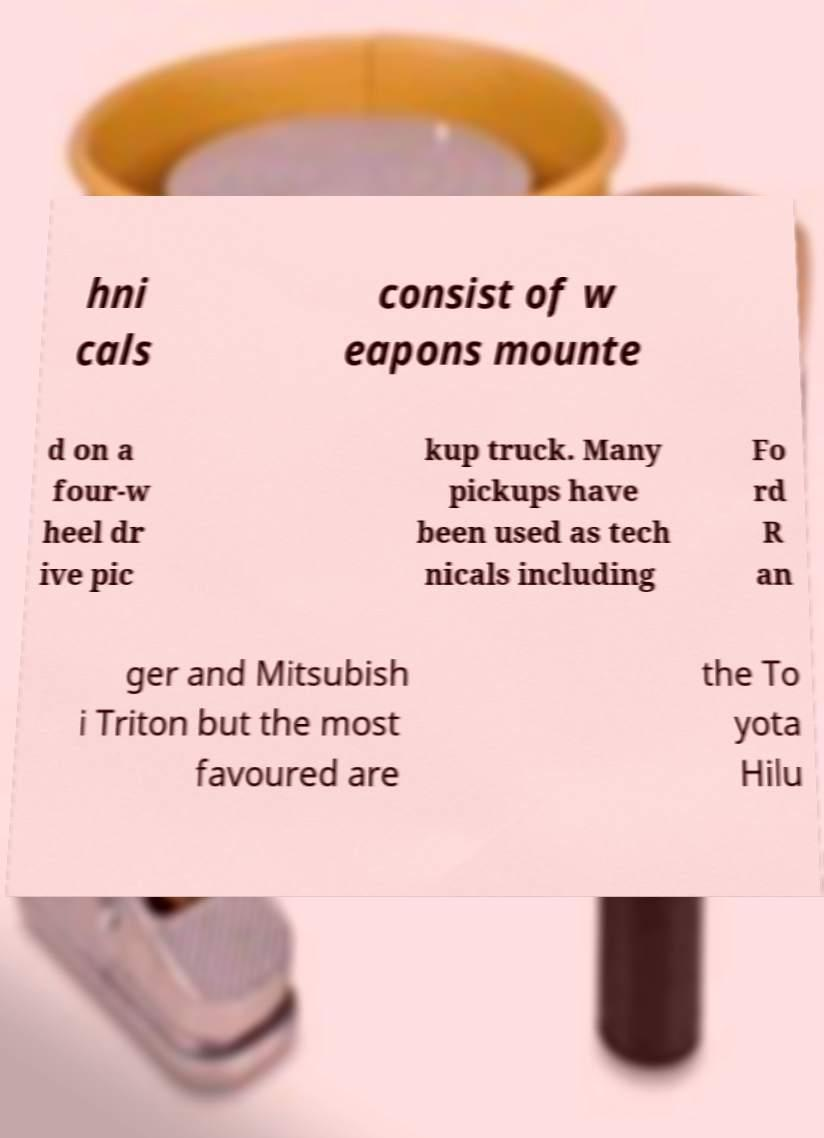For documentation purposes, I need the text within this image transcribed. Could you provide that? hni cals consist of w eapons mounte d on a four-w heel dr ive pic kup truck. Many pickups have been used as tech nicals including Fo rd R an ger and Mitsubish i Triton but the most favoured are the To yota Hilu 